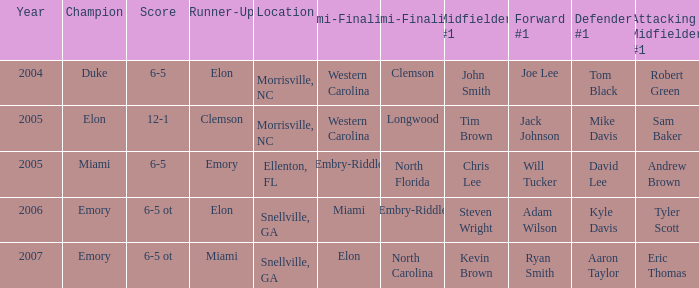List the scores of all games when Miami were listed as the first Semi finalist 6-5 ot. 